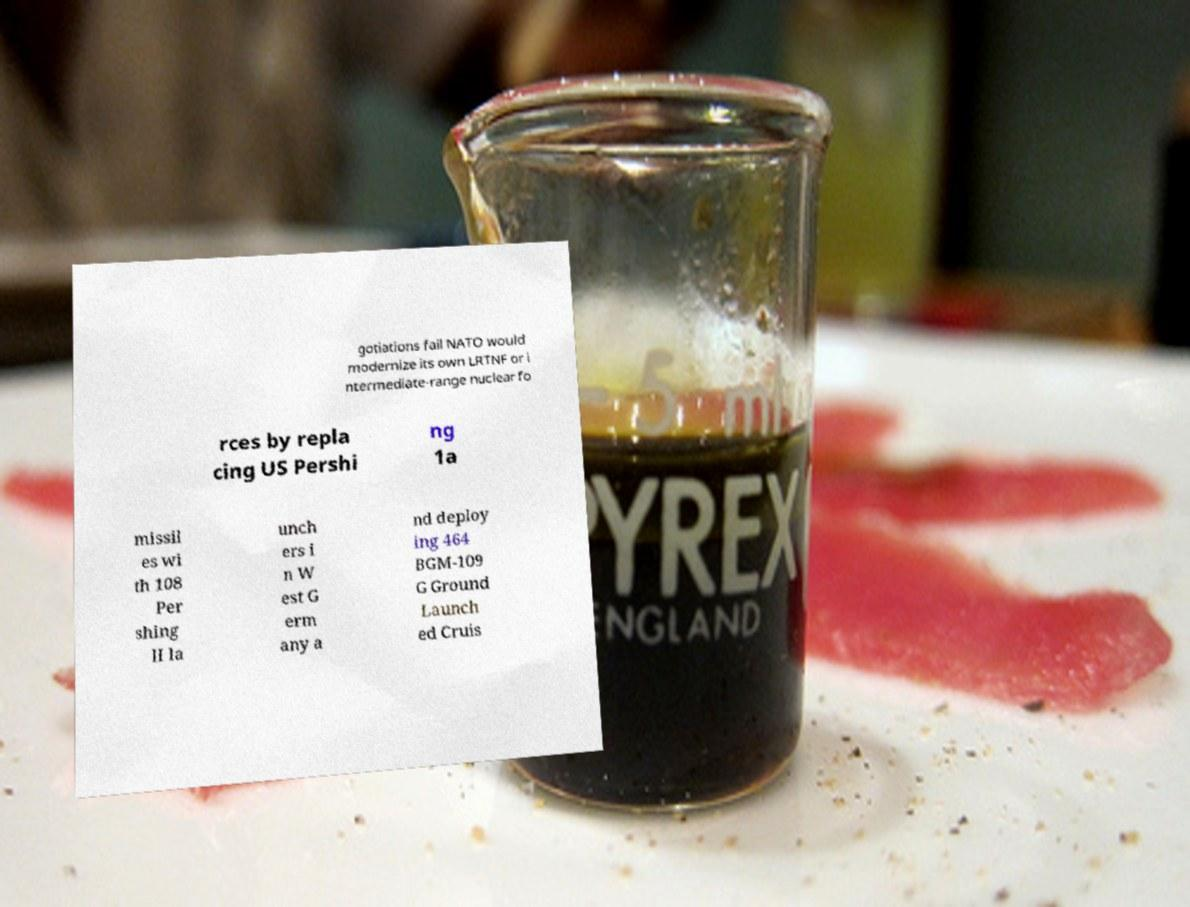Please read and relay the text visible in this image. What does it say? gotiations fail NATO would modernize its own LRTNF or i ntermediate-range nuclear fo rces by repla cing US Pershi ng 1a missil es wi th 108 Per shing II la unch ers i n W est G erm any a nd deploy ing 464 BGM-109 G Ground Launch ed Cruis 